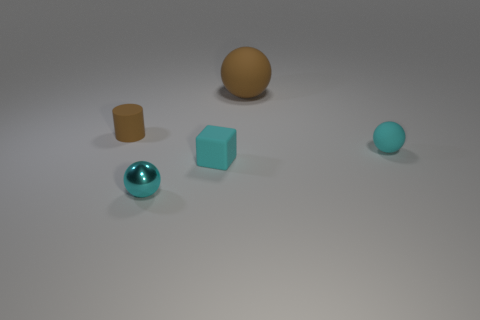Add 4 large green metallic blocks. How many objects exist? 9 Subtract all blocks. How many objects are left? 4 Subtract all small cubes. Subtract all big brown rubber balls. How many objects are left? 3 Add 2 small cyan things. How many small cyan things are left? 5 Add 2 shiny cubes. How many shiny cubes exist? 2 Subtract 0 green cylinders. How many objects are left? 5 